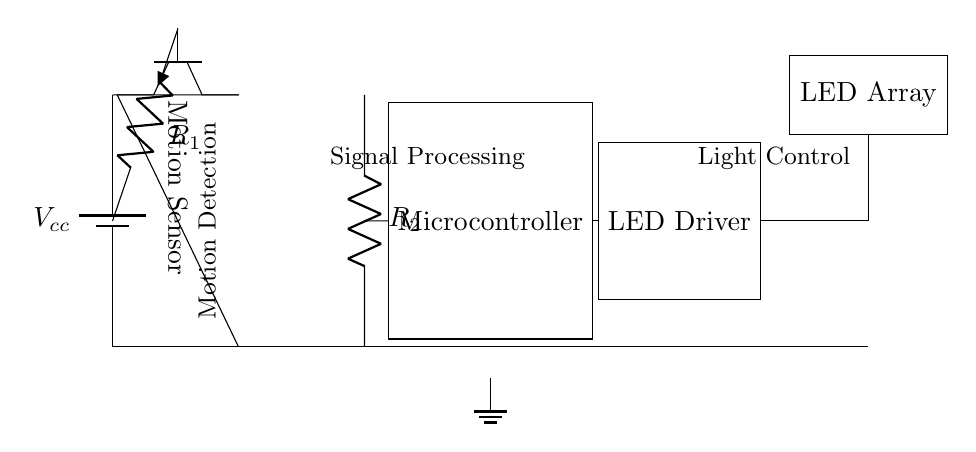What is the main component used for motion detection? The main component used for motion detection is the Motion Sensor, indicated in the diagram as an NPN transistor.
Answer: Motion Sensor What is the role of the microcontroller in this circuit? The microcontroller processes the signal received from the motion sensor and controls the LED driver based on that signal, thus acting as the brain of the circuit.
Answer: Signal Processing How many resistors are present in this circuit? There are two resistors in the circuit, labeled R1 and R2.
Answer: Two What type of load is controlled by the LED driver? The load controlled by the LED driver is the LED Array, which lights up based on the processed signals.
Answer: LED Array What is the function of resistor R1? Resistor R1 is used to limit the current flowing into the motion sensor, ensuring that it operates within safe parameters and avoids damage.
Answer: Current Limiting What happens if a motion is detected? If motion is detected, the motion sensor sends a signal to the microcontroller, which then triggers the LED driver to turn on the LED Array, illuminating the area.
Answer: Lights Turn On What is the source of power for this circuit? The source of power for the circuit is the battery labeled Vcc, which supplies the necessary voltage to the other components.
Answer: Battery 